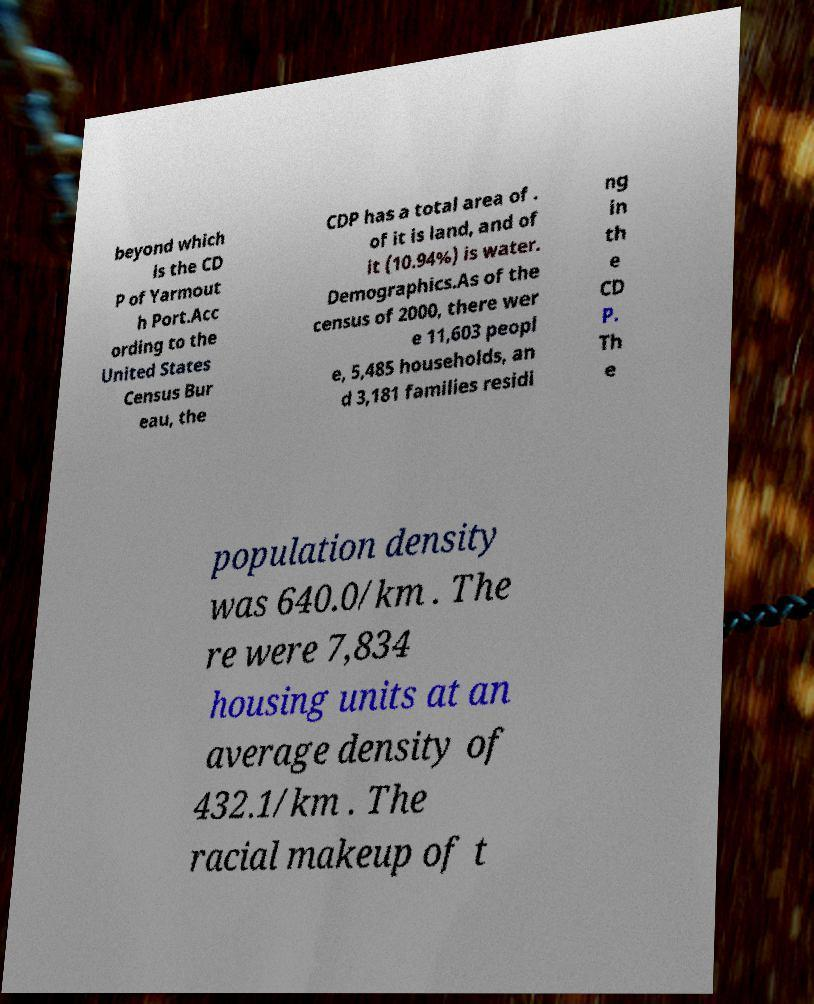There's text embedded in this image that I need extracted. Can you transcribe it verbatim? beyond which is the CD P of Yarmout h Port.Acc ording to the United States Census Bur eau, the CDP has a total area of . of it is land, and of it (10.94%) is water. Demographics.As of the census of 2000, there wer e 11,603 peopl e, 5,485 households, an d 3,181 families residi ng in th e CD P. Th e population density was 640.0/km . The re were 7,834 housing units at an average density of 432.1/km . The racial makeup of t 